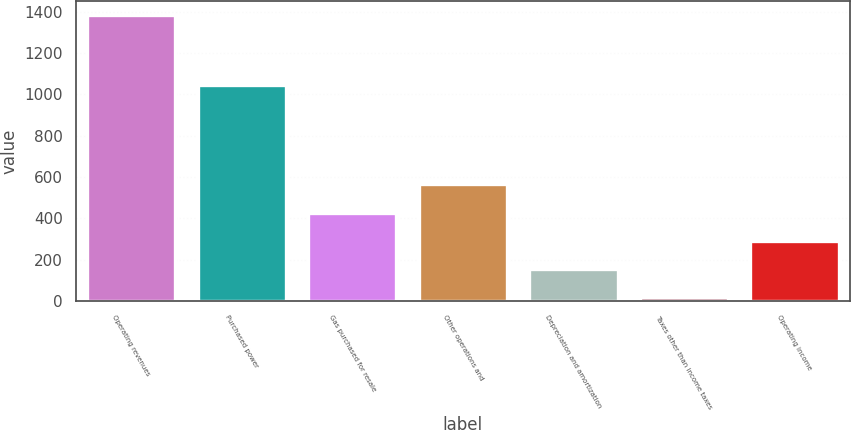Convert chart. <chart><loc_0><loc_0><loc_500><loc_500><bar_chart><fcel>Operating revenues<fcel>Purchased power<fcel>Gas purchased for resale<fcel>Other operations and<fcel>Depreciation and amortization<fcel>Taxes other than income taxes<fcel>Operating income<nl><fcel>1383<fcel>1044<fcel>428.2<fcel>564.6<fcel>155.4<fcel>19<fcel>291.8<nl></chart> 